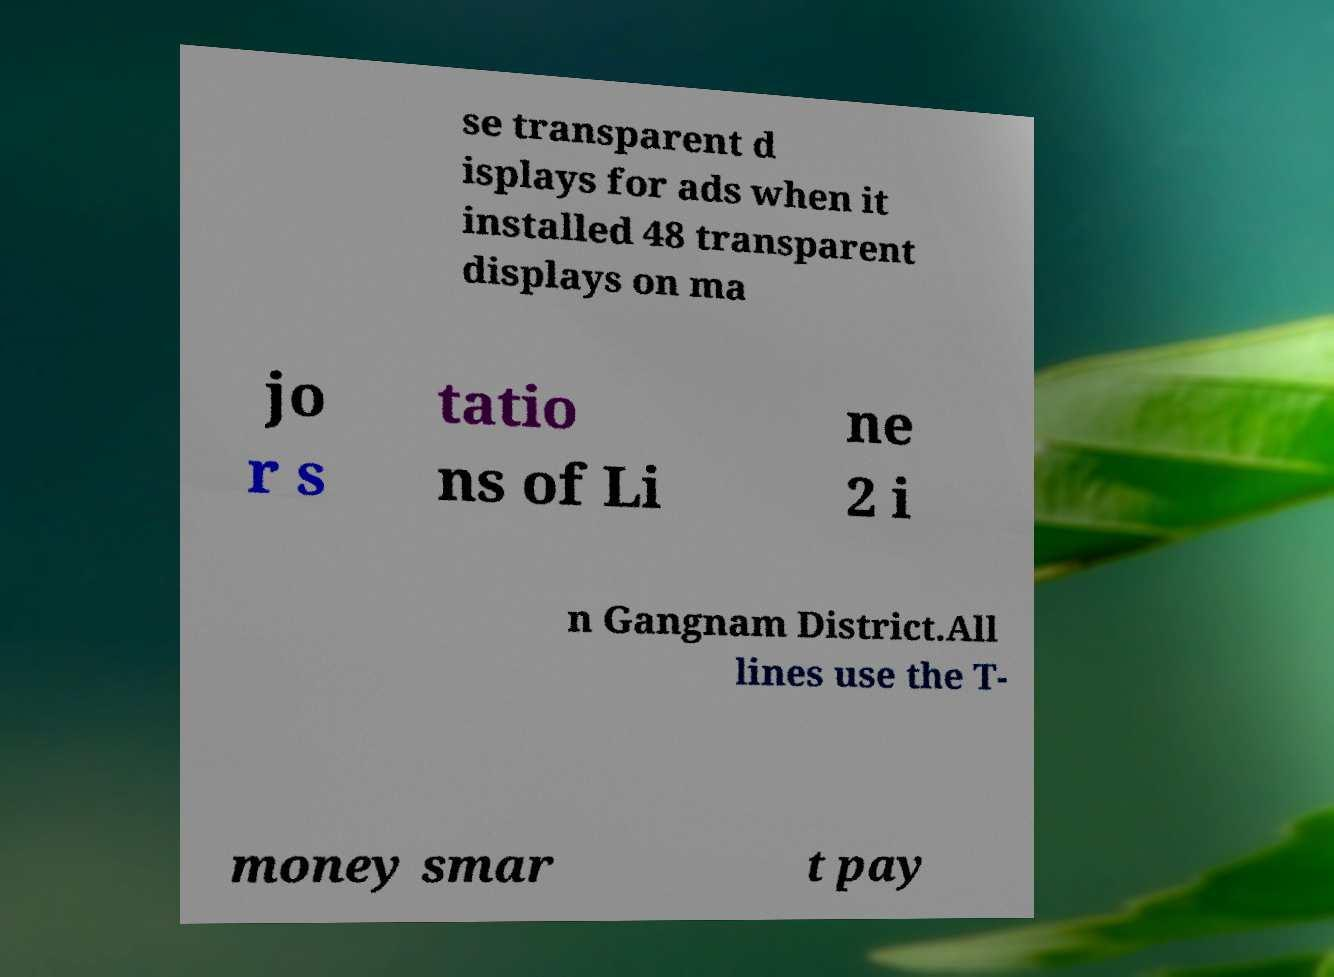Can you read and provide the text displayed in the image?This photo seems to have some interesting text. Can you extract and type it out for me? se transparent d isplays for ads when it installed 48 transparent displays on ma jo r s tatio ns of Li ne 2 i n Gangnam District.All lines use the T- money smar t pay 